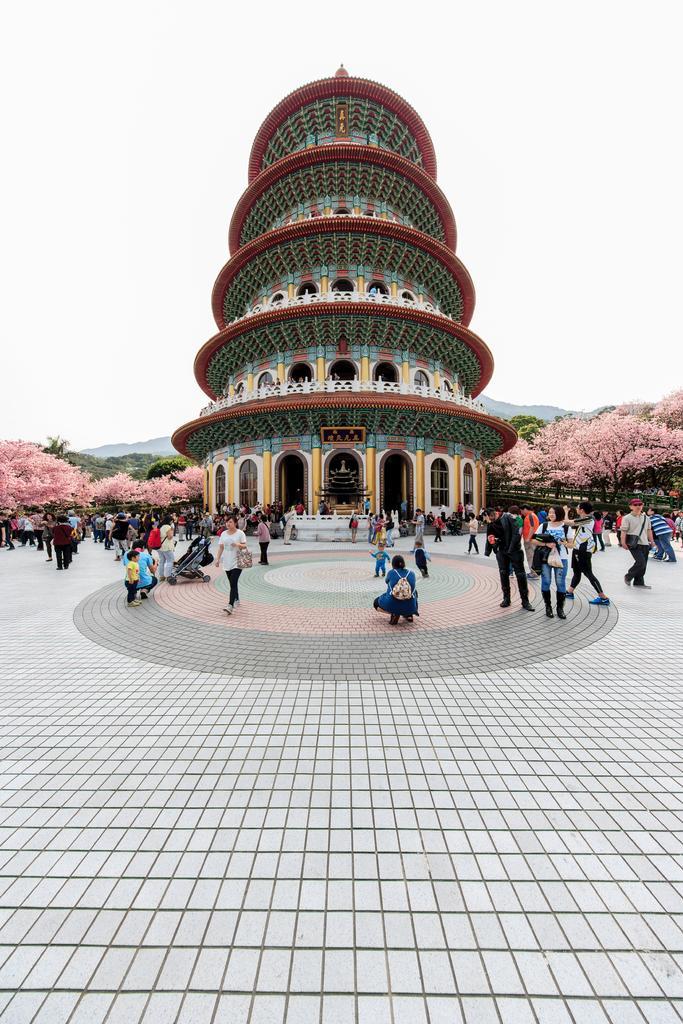Could you give a brief overview of what you see in this image? In the background we can see the sky. In this picture we can see the trees, designed building and few objects. We can see the people. We can see a person wearing a backpack and the person is in a squat position. 